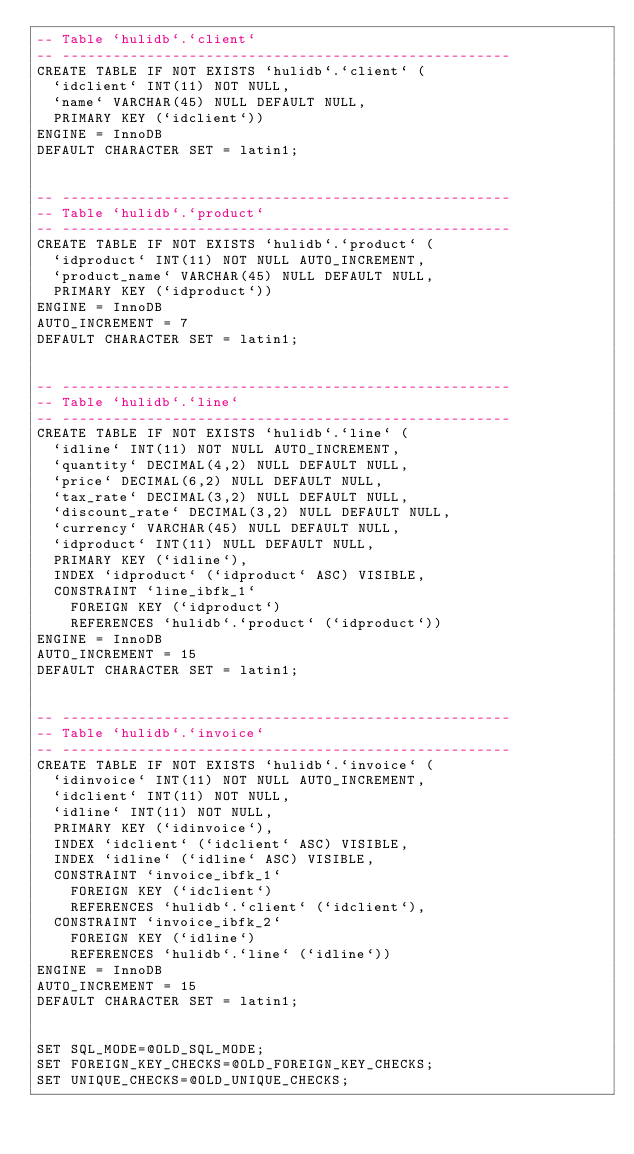Convert code to text. <code><loc_0><loc_0><loc_500><loc_500><_SQL_>-- Table `hulidb`.`client`
-- -----------------------------------------------------
CREATE TABLE IF NOT EXISTS `hulidb`.`client` (
  `idclient` INT(11) NOT NULL,
  `name` VARCHAR(45) NULL DEFAULT NULL,
  PRIMARY KEY (`idclient`))
ENGINE = InnoDB
DEFAULT CHARACTER SET = latin1;


-- -----------------------------------------------------
-- Table `hulidb`.`product`
-- -----------------------------------------------------
CREATE TABLE IF NOT EXISTS `hulidb`.`product` (
  `idproduct` INT(11) NOT NULL AUTO_INCREMENT,
  `product_name` VARCHAR(45) NULL DEFAULT NULL,
  PRIMARY KEY (`idproduct`))
ENGINE = InnoDB
AUTO_INCREMENT = 7
DEFAULT CHARACTER SET = latin1;


-- -----------------------------------------------------
-- Table `hulidb`.`line`
-- -----------------------------------------------------
CREATE TABLE IF NOT EXISTS `hulidb`.`line` (
  `idline` INT(11) NOT NULL AUTO_INCREMENT,
  `quantity` DECIMAL(4,2) NULL DEFAULT NULL,
  `price` DECIMAL(6,2) NULL DEFAULT NULL,
  `tax_rate` DECIMAL(3,2) NULL DEFAULT NULL,
  `discount_rate` DECIMAL(3,2) NULL DEFAULT NULL,
  `currency` VARCHAR(45) NULL DEFAULT NULL,
  `idproduct` INT(11) NULL DEFAULT NULL,
  PRIMARY KEY (`idline`),
  INDEX `idproduct` (`idproduct` ASC) VISIBLE,
  CONSTRAINT `line_ibfk_1`
    FOREIGN KEY (`idproduct`)
    REFERENCES `hulidb`.`product` (`idproduct`))
ENGINE = InnoDB
AUTO_INCREMENT = 15
DEFAULT CHARACTER SET = latin1;


-- -----------------------------------------------------
-- Table `hulidb`.`invoice`
-- -----------------------------------------------------
CREATE TABLE IF NOT EXISTS `hulidb`.`invoice` (
  `idinvoice` INT(11) NOT NULL AUTO_INCREMENT,
  `idclient` INT(11) NOT NULL,
  `idline` INT(11) NOT NULL,
  PRIMARY KEY (`idinvoice`),
  INDEX `idclient` (`idclient` ASC) VISIBLE,
  INDEX `idline` (`idline` ASC) VISIBLE,
  CONSTRAINT `invoice_ibfk_1`
    FOREIGN KEY (`idclient`)
    REFERENCES `hulidb`.`client` (`idclient`),
  CONSTRAINT `invoice_ibfk_2`
    FOREIGN KEY (`idline`)
    REFERENCES `hulidb`.`line` (`idline`))
ENGINE = InnoDB
AUTO_INCREMENT = 15
DEFAULT CHARACTER SET = latin1;


SET SQL_MODE=@OLD_SQL_MODE;
SET FOREIGN_KEY_CHECKS=@OLD_FOREIGN_KEY_CHECKS;
SET UNIQUE_CHECKS=@OLD_UNIQUE_CHECKS;
</code> 